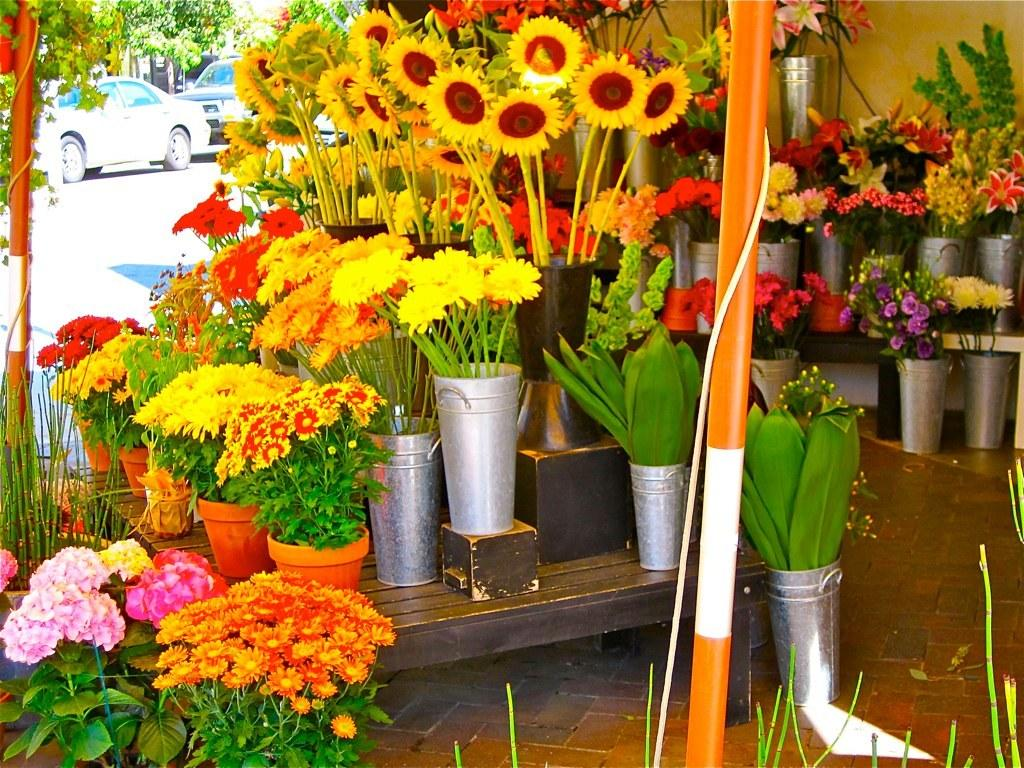What type of objects can be seen in the image? There are flower pots in the image. Can you describe the background of the image? There are vehicles visible in the background of the image. What type of nut is being observed in the image? There is no nut present in the image; it features flower pots and vehicles in the background. 